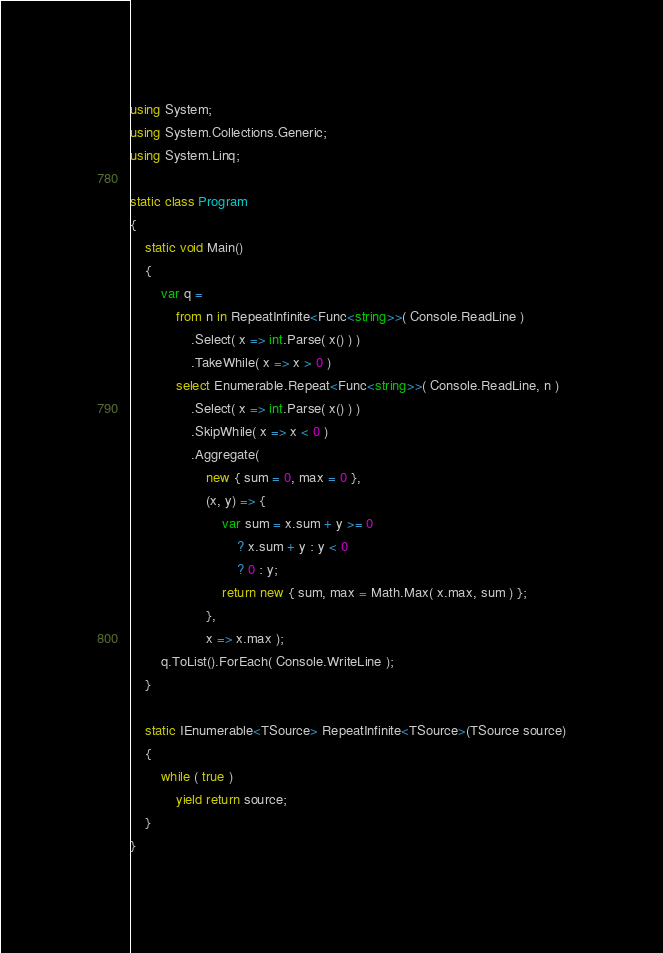Convert code to text. <code><loc_0><loc_0><loc_500><loc_500><_C#_>using System;
using System.Collections.Generic;
using System.Linq;

static class Program
{
    static void Main()
    {
        var q =
            from n in RepeatInfinite<Func<string>>( Console.ReadLine )
                .Select( x => int.Parse( x() ) )
                .TakeWhile( x => x > 0 )
            select Enumerable.Repeat<Func<string>>( Console.ReadLine, n )
                .Select( x => int.Parse( x() ) )
                .SkipWhile( x => x < 0 )
                .Aggregate(
                    new { sum = 0, max = 0 },
                    (x, y) => {
                        var sum = x.sum + y >= 0 
                            ? x.sum + y : y < 0 
                            ? 0 : y;
                        return new { sum, max = Math.Max( x.max, sum ) };
                    },
                    x => x.max );
        q.ToList().ForEach( Console.WriteLine );
    }

    static IEnumerable<TSource> RepeatInfinite<TSource>(TSource source)
    {
        while ( true )
            yield return source;
    }
}</code> 